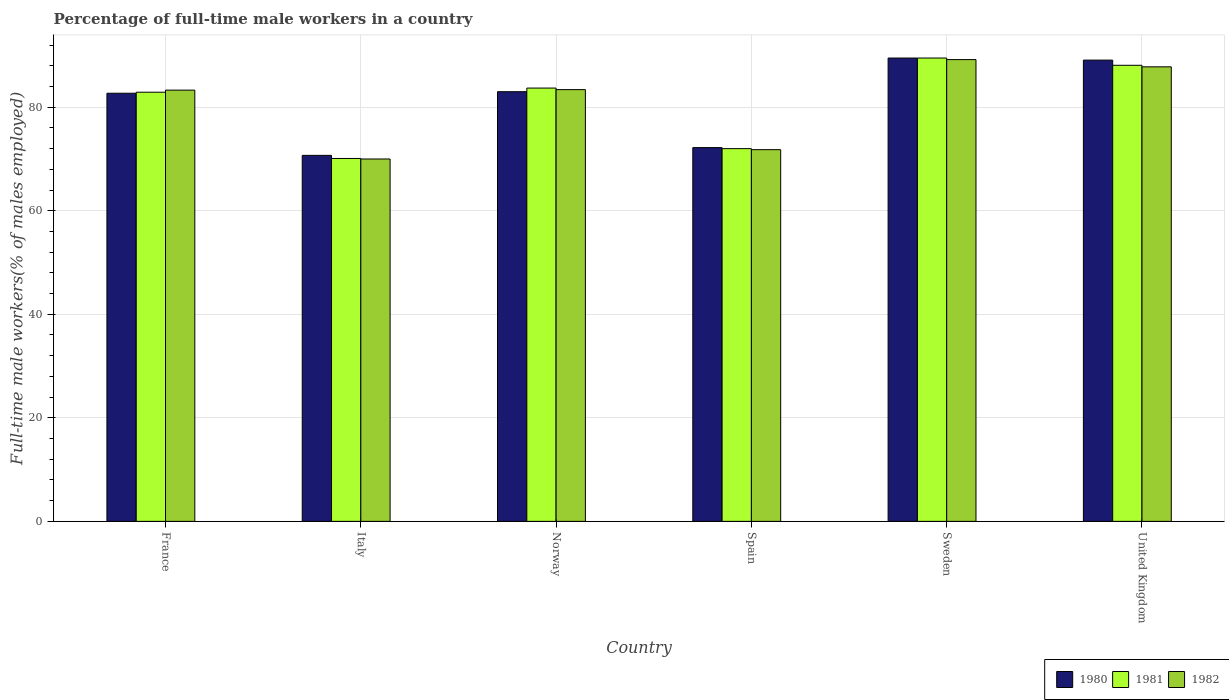How many different coloured bars are there?
Your response must be concise. 3. Are the number of bars on each tick of the X-axis equal?
Provide a short and direct response. Yes. How many bars are there on the 3rd tick from the right?
Offer a very short reply. 3. What is the label of the 3rd group of bars from the left?
Provide a succinct answer. Norway. What is the percentage of full-time male workers in 1981 in Italy?
Make the answer very short. 70.1. Across all countries, what is the maximum percentage of full-time male workers in 1982?
Offer a terse response. 89.2. Across all countries, what is the minimum percentage of full-time male workers in 1980?
Provide a short and direct response. 70.7. In which country was the percentage of full-time male workers in 1980 maximum?
Offer a terse response. Sweden. What is the total percentage of full-time male workers in 1982 in the graph?
Your answer should be very brief. 485.5. What is the difference between the percentage of full-time male workers in 1981 in France and that in Sweden?
Your response must be concise. -6.6. What is the difference between the percentage of full-time male workers in 1982 in Norway and the percentage of full-time male workers in 1980 in Italy?
Offer a very short reply. 12.7. What is the average percentage of full-time male workers in 1980 per country?
Keep it short and to the point. 81.2. What is the difference between the percentage of full-time male workers of/in 1982 and percentage of full-time male workers of/in 1981 in Norway?
Offer a very short reply. -0.3. In how many countries, is the percentage of full-time male workers in 1982 greater than 48 %?
Your response must be concise. 6. What is the ratio of the percentage of full-time male workers in 1980 in Norway to that in United Kingdom?
Offer a terse response. 0.93. What is the difference between the highest and the second highest percentage of full-time male workers in 1980?
Provide a short and direct response. -0.4. What is the difference between the highest and the lowest percentage of full-time male workers in 1981?
Your answer should be compact. 19.4. In how many countries, is the percentage of full-time male workers in 1982 greater than the average percentage of full-time male workers in 1982 taken over all countries?
Your answer should be compact. 4. Is the sum of the percentage of full-time male workers in 1980 in Spain and United Kingdom greater than the maximum percentage of full-time male workers in 1981 across all countries?
Your response must be concise. Yes. What does the 1st bar from the left in Sweden represents?
Make the answer very short. 1980. Is it the case that in every country, the sum of the percentage of full-time male workers in 1981 and percentage of full-time male workers in 1982 is greater than the percentage of full-time male workers in 1980?
Keep it short and to the point. Yes. How many bars are there?
Provide a succinct answer. 18. Are all the bars in the graph horizontal?
Keep it short and to the point. No. How many countries are there in the graph?
Offer a very short reply. 6. What is the difference between two consecutive major ticks on the Y-axis?
Your answer should be compact. 20. Are the values on the major ticks of Y-axis written in scientific E-notation?
Provide a short and direct response. No. Does the graph contain any zero values?
Your answer should be compact. No. Does the graph contain grids?
Ensure brevity in your answer.  Yes. Where does the legend appear in the graph?
Keep it short and to the point. Bottom right. How many legend labels are there?
Provide a succinct answer. 3. What is the title of the graph?
Offer a terse response. Percentage of full-time male workers in a country. What is the label or title of the X-axis?
Provide a short and direct response. Country. What is the label or title of the Y-axis?
Offer a terse response. Full-time male workers(% of males employed). What is the Full-time male workers(% of males employed) of 1980 in France?
Ensure brevity in your answer.  82.7. What is the Full-time male workers(% of males employed) in 1981 in France?
Give a very brief answer. 82.9. What is the Full-time male workers(% of males employed) of 1982 in France?
Offer a terse response. 83.3. What is the Full-time male workers(% of males employed) in 1980 in Italy?
Your response must be concise. 70.7. What is the Full-time male workers(% of males employed) of 1981 in Italy?
Make the answer very short. 70.1. What is the Full-time male workers(% of males employed) of 1982 in Italy?
Keep it short and to the point. 70. What is the Full-time male workers(% of males employed) of 1981 in Norway?
Offer a terse response. 83.7. What is the Full-time male workers(% of males employed) of 1982 in Norway?
Make the answer very short. 83.4. What is the Full-time male workers(% of males employed) in 1980 in Spain?
Provide a short and direct response. 72.2. What is the Full-time male workers(% of males employed) of 1982 in Spain?
Provide a succinct answer. 71.8. What is the Full-time male workers(% of males employed) of 1980 in Sweden?
Provide a succinct answer. 89.5. What is the Full-time male workers(% of males employed) in 1981 in Sweden?
Ensure brevity in your answer.  89.5. What is the Full-time male workers(% of males employed) in 1982 in Sweden?
Provide a short and direct response. 89.2. What is the Full-time male workers(% of males employed) of 1980 in United Kingdom?
Your answer should be very brief. 89.1. What is the Full-time male workers(% of males employed) of 1981 in United Kingdom?
Offer a very short reply. 88.1. What is the Full-time male workers(% of males employed) in 1982 in United Kingdom?
Your answer should be compact. 87.8. Across all countries, what is the maximum Full-time male workers(% of males employed) in 1980?
Give a very brief answer. 89.5. Across all countries, what is the maximum Full-time male workers(% of males employed) of 1981?
Ensure brevity in your answer.  89.5. Across all countries, what is the maximum Full-time male workers(% of males employed) of 1982?
Make the answer very short. 89.2. Across all countries, what is the minimum Full-time male workers(% of males employed) in 1980?
Ensure brevity in your answer.  70.7. Across all countries, what is the minimum Full-time male workers(% of males employed) of 1981?
Your answer should be compact. 70.1. Across all countries, what is the minimum Full-time male workers(% of males employed) of 1982?
Your response must be concise. 70. What is the total Full-time male workers(% of males employed) in 1980 in the graph?
Provide a succinct answer. 487.2. What is the total Full-time male workers(% of males employed) of 1981 in the graph?
Provide a succinct answer. 486.3. What is the total Full-time male workers(% of males employed) in 1982 in the graph?
Your answer should be very brief. 485.5. What is the difference between the Full-time male workers(% of males employed) in 1981 in France and that in Italy?
Offer a terse response. 12.8. What is the difference between the Full-time male workers(% of males employed) in 1980 in France and that in Norway?
Provide a short and direct response. -0.3. What is the difference between the Full-time male workers(% of males employed) in 1981 in France and that in Norway?
Your answer should be compact. -0.8. What is the difference between the Full-time male workers(% of males employed) of 1982 in France and that in Norway?
Offer a very short reply. -0.1. What is the difference between the Full-time male workers(% of males employed) of 1981 in France and that in Sweden?
Make the answer very short. -6.6. What is the difference between the Full-time male workers(% of males employed) of 1982 in France and that in Sweden?
Provide a short and direct response. -5.9. What is the difference between the Full-time male workers(% of males employed) in 1981 in France and that in United Kingdom?
Your answer should be compact. -5.2. What is the difference between the Full-time male workers(% of males employed) in 1981 in Italy and that in Norway?
Your answer should be compact. -13.6. What is the difference between the Full-time male workers(% of males employed) in 1982 in Italy and that in Norway?
Offer a very short reply. -13.4. What is the difference between the Full-time male workers(% of males employed) of 1980 in Italy and that in Spain?
Offer a very short reply. -1.5. What is the difference between the Full-time male workers(% of males employed) in 1981 in Italy and that in Spain?
Offer a terse response. -1.9. What is the difference between the Full-time male workers(% of males employed) of 1980 in Italy and that in Sweden?
Offer a very short reply. -18.8. What is the difference between the Full-time male workers(% of males employed) of 1981 in Italy and that in Sweden?
Your answer should be compact. -19.4. What is the difference between the Full-time male workers(% of males employed) in 1982 in Italy and that in Sweden?
Offer a very short reply. -19.2. What is the difference between the Full-time male workers(% of males employed) of 1980 in Italy and that in United Kingdom?
Your answer should be very brief. -18.4. What is the difference between the Full-time male workers(% of males employed) of 1982 in Italy and that in United Kingdom?
Offer a terse response. -17.8. What is the difference between the Full-time male workers(% of males employed) of 1981 in Norway and that in Spain?
Your answer should be very brief. 11.7. What is the difference between the Full-time male workers(% of males employed) of 1980 in Norway and that in Sweden?
Ensure brevity in your answer.  -6.5. What is the difference between the Full-time male workers(% of males employed) of 1980 in Norway and that in United Kingdom?
Keep it short and to the point. -6.1. What is the difference between the Full-time male workers(% of males employed) of 1980 in Spain and that in Sweden?
Provide a short and direct response. -17.3. What is the difference between the Full-time male workers(% of males employed) of 1981 in Spain and that in Sweden?
Your response must be concise. -17.5. What is the difference between the Full-time male workers(% of males employed) of 1982 in Spain and that in Sweden?
Give a very brief answer. -17.4. What is the difference between the Full-time male workers(% of males employed) in 1980 in Spain and that in United Kingdom?
Provide a succinct answer. -16.9. What is the difference between the Full-time male workers(% of males employed) of 1981 in Spain and that in United Kingdom?
Your response must be concise. -16.1. What is the difference between the Full-time male workers(% of males employed) in 1982 in Spain and that in United Kingdom?
Provide a succinct answer. -16. What is the difference between the Full-time male workers(% of males employed) in 1980 in Sweden and that in United Kingdom?
Ensure brevity in your answer.  0.4. What is the difference between the Full-time male workers(% of males employed) of 1982 in Sweden and that in United Kingdom?
Keep it short and to the point. 1.4. What is the difference between the Full-time male workers(% of males employed) of 1980 in France and the Full-time male workers(% of males employed) of 1981 in Italy?
Make the answer very short. 12.6. What is the difference between the Full-time male workers(% of males employed) of 1981 in France and the Full-time male workers(% of males employed) of 1982 in Italy?
Provide a short and direct response. 12.9. What is the difference between the Full-time male workers(% of males employed) of 1980 in France and the Full-time male workers(% of males employed) of 1981 in Norway?
Give a very brief answer. -1. What is the difference between the Full-time male workers(% of males employed) of 1981 in France and the Full-time male workers(% of males employed) of 1982 in Norway?
Offer a very short reply. -0.5. What is the difference between the Full-time male workers(% of males employed) of 1980 in France and the Full-time male workers(% of males employed) of 1981 in Spain?
Ensure brevity in your answer.  10.7. What is the difference between the Full-time male workers(% of males employed) in 1980 in France and the Full-time male workers(% of males employed) in 1981 in Sweden?
Keep it short and to the point. -6.8. What is the difference between the Full-time male workers(% of males employed) of 1981 in France and the Full-time male workers(% of males employed) of 1982 in Sweden?
Make the answer very short. -6.3. What is the difference between the Full-time male workers(% of males employed) in 1980 in France and the Full-time male workers(% of males employed) in 1981 in United Kingdom?
Ensure brevity in your answer.  -5.4. What is the difference between the Full-time male workers(% of males employed) of 1980 in France and the Full-time male workers(% of males employed) of 1982 in United Kingdom?
Your answer should be very brief. -5.1. What is the difference between the Full-time male workers(% of males employed) of 1981 in France and the Full-time male workers(% of males employed) of 1982 in United Kingdom?
Offer a terse response. -4.9. What is the difference between the Full-time male workers(% of males employed) of 1980 in Italy and the Full-time male workers(% of males employed) of 1982 in Norway?
Your response must be concise. -12.7. What is the difference between the Full-time male workers(% of males employed) in 1980 in Italy and the Full-time male workers(% of males employed) in 1982 in Spain?
Your response must be concise. -1.1. What is the difference between the Full-time male workers(% of males employed) of 1980 in Italy and the Full-time male workers(% of males employed) of 1981 in Sweden?
Offer a very short reply. -18.8. What is the difference between the Full-time male workers(% of males employed) in 1980 in Italy and the Full-time male workers(% of males employed) in 1982 in Sweden?
Your response must be concise. -18.5. What is the difference between the Full-time male workers(% of males employed) in 1981 in Italy and the Full-time male workers(% of males employed) in 1982 in Sweden?
Your answer should be compact. -19.1. What is the difference between the Full-time male workers(% of males employed) in 1980 in Italy and the Full-time male workers(% of males employed) in 1981 in United Kingdom?
Provide a succinct answer. -17.4. What is the difference between the Full-time male workers(% of males employed) of 1980 in Italy and the Full-time male workers(% of males employed) of 1982 in United Kingdom?
Provide a short and direct response. -17.1. What is the difference between the Full-time male workers(% of males employed) of 1981 in Italy and the Full-time male workers(% of males employed) of 1982 in United Kingdom?
Your answer should be very brief. -17.7. What is the difference between the Full-time male workers(% of males employed) in 1980 in Norway and the Full-time male workers(% of males employed) in 1982 in Spain?
Your response must be concise. 11.2. What is the difference between the Full-time male workers(% of males employed) of 1980 in Norway and the Full-time male workers(% of males employed) of 1981 in Sweden?
Offer a terse response. -6.5. What is the difference between the Full-time male workers(% of males employed) of 1980 in Norway and the Full-time male workers(% of males employed) of 1982 in Sweden?
Offer a very short reply. -6.2. What is the difference between the Full-time male workers(% of males employed) of 1981 in Norway and the Full-time male workers(% of males employed) of 1982 in United Kingdom?
Ensure brevity in your answer.  -4.1. What is the difference between the Full-time male workers(% of males employed) in 1980 in Spain and the Full-time male workers(% of males employed) in 1981 in Sweden?
Offer a terse response. -17.3. What is the difference between the Full-time male workers(% of males employed) of 1981 in Spain and the Full-time male workers(% of males employed) of 1982 in Sweden?
Offer a very short reply. -17.2. What is the difference between the Full-time male workers(% of males employed) in 1980 in Spain and the Full-time male workers(% of males employed) in 1981 in United Kingdom?
Offer a very short reply. -15.9. What is the difference between the Full-time male workers(% of males employed) of 1980 in Spain and the Full-time male workers(% of males employed) of 1982 in United Kingdom?
Your answer should be compact. -15.6. What is the difference between the Full-time male workers(% of males employed) in 1981 in Spain and the Full-time male workers(% of males employed) in 1982 in United Kingdom?
Ensure brevity in your answer.  -15.8. What is the average Full-time male workers(% of males employed) of 1980 per country?
Provide a short and direct response. 81.2. What is the average Full-time male workers(% of males employed) of 1981 per country?
Offer a very short reply. 81.05. What is the average Full-time male workers(% of males employed) of 1982 per country?
Give a very brief answer. 80.92. What is the difference between the Full-time male workers(% of males employed) in 1980 and Full-time male workers(% of males employed) in 1981 in France?
Provide a succinct answer. -0.2. What is the difference between the Full-time male workers(% of males employed) in 1980 and Full-time male workers(% of males employed) in 1982 in Italy?
Your answer should be compact. 0.7. What is the difference between the Full-time male workers(% of males employed) of 1981 and Full-time male workers(% of males employed) of 1982 in Italy?
Ensure brevity in your answer.  0.1. What is the difference between the Full-time male workers(% of males employed) of 1980 and Full-time male workers(% of males employed) of 1982 in Norway?
Keep it short and to the point. -0.4. What is the difference between the Full-time male workers(% of males employed) of 1981 and Full-time male workers(% of males employed) of 1982 in Norway?
Make the answer very short. 0.3. What is the difference between the Full-time male workers(% of males employed) in 1980 and Full-time male workers(% of males employed) in 1982 in Spain?
Your answer should be very brief. 0.4. What is the difference between the Full-time male workers(% of males employed) of 1981 and Full-time male workers(% of males employed) of 1982 in Spain?
Your answer should be very brief. 0.2. What is the difference between the Full-time male workers(% of males employed) in 1980 and Full-time male workers(% of males employed) in 1982 in United Kingdom?
Make the answer very short. 1.3. What is the difference between the Full-time male workers(% of males employed) of 1981 and Full-time male workers(% of males employed) of 1982 in United Kingdom?
Offer a very short reply. 0.3. What is the ratio of the Full-time male workers(% of males employed) in 1980 in France to that in Italy?
Ensure brevity in your answer.  1.17. What is the ratio of the Full-time male workers(% of males employed) in 1981 in France to that in Italy?
Provide a short and direct response. 1.18. What is the ratio of the Full-time male workers(% of males employed) of 1982 in France to that in Italy?
Ensure brevity in your answer.  1.19. What is the ratio of the Full-time male workers(% of males employed) in 1980 in France to that in Norway?
Keep it short and to the point. 1. What is the ratio of the Full-time male workers(% of males employed) in 1981 in France to that in Norway?
Give a very brief answer. 0.99. What is the ratio of the Full-time male workers(% of males employed) of 1980 in France to that in Spain?
Your answer should be compact. 1.15. What is the ratio of the Full-time male workers(% of males employed) of 1981 in France to that in Spain?
Give a very brief answer. 1.15. What is the ratio of the Full-time male workers(% of males employed) of 1982 in France to that in Spain?
Keep it short and to the point. 1.16. What is the ratio of the Full-time male workers(% of males employed) in 1980 in France to that in Sweden?
Your answer should be very brief. 0.92. What is the ratio of the Full-time male workers(% of males employed) of 1981 in France to that in Sweden?
Your answer should be very brief. 0.93. What is the ratio of the Full-time male workers(% of males employed) in 1982 in France to that in Sweden?
Provide a succinct answer. 0.93. What is the ratio of the Full-time male workers(% of males employed) of 1980 in France to that in United Kingdom?
Keep it short and to the point. 0.93. What is the ratio of the Full-time male workers(% of males employed) in 1981 in France to that in United Kingdom?
Make the answer very short. 0.94. What is the ratio of the Full-time male workers(% of males employed) of 1982 in France to that in United Kingdom?
Keep it short and to the point. 0.95. What is the ratio of the Full-time male workers(% of males employed) of 1980 in Italy to that in Norway?
Your response must be concise. 0.85. What is the ratio of the Full-time male workers(% of males employed) of 1981 in Italy to that in Norway?
Your answer should be compact. 0.84. What is the ratio of the Full-time male workers(% of males employed) in 1982 in Italy to that in Norway?
Offer a terse response. 0.84. What is the ratio of the Full-time male workers(% of males employed) of 1980 in Italy to that in Spain?
Provide a succinct answer. 0.98. What is the ratio of the Full-time male workers(% of males employed) in 1981 in Italy to that in Spain?
Provide a short and direct response. 0.97. What is the ratio of the Full-time male workers(% of males employed) of 1982 in Italy to that in Spain?
Make the answer very short. 0.97. What is the ratio of the Full-time male workers(% of males employed) in 1980 in Italy to that in Sweden?
Keep it short and to the point. 0.79. What is the ratio of the Full-time male workers(% of males employed) in 1981 in Italy to that in Sweden?
Provide a short and direct response. 0.78. What is the ratio of the Full-time male workers(% of males employed) of 1982 in Italy to that in Sweden?
Your answer should be very brief. 0.78. What is the ratio of the Full-time male workers(% of males employed) in 1980 in Italy to that in United Kingdom?
Provide a succinct answer. 0.79. What is the ratio of the Full-time male workers(% of males employed) in 1981 in Italy to that in United Kingdom?
Your answer should be very brief. 0.8. What is the ratio of the Full-time male workers(% of males employed) in 1982 in Italy to that in United Kingdom?
Provide a short and direct response. 0.8. What is the ratio of the Full-time male workers(% of males employed) of 1980 in Norway to that in Spain?
Give a very brief answer. 1.15. What is the ratio of the Full-time male workers(% of males employed) in 1981 in Norway to that in Spain?
Offer a terse response. 1.16. What is the ratio of the Full-time male workers(% of males employed) in 1982 in Norway to that in Spain?
Offer a terse response. 1.16. What is the ratio of the Full-time male workers(% of males employed) of 1980 in Norway to that in Sweden?
Your response must be concise. 0.93. What is the ratio of the Full-time male workers(% of males employed) of 1981 in Norway to that in Sweden?
Offer a terse response. 0.94. What is the ratio of the Full-time male workers(% of males employed) of 1982 in Norway to that in Sweden?
Your answer should be compact. 0.94. What is the ratio of the Full-time male workers(% of males employed) in 1980 in Norway to that in United Kingdom?
Offer a terse response. 0.93. What is the ratio of the Full-time male workers(% of males employed) in 1981 in Norway to that in United Kingdom?
Your response must be concise. 0.95. What is the ratio of the Full-time male workers(% of males employed) of 1982 in Norway to that in United Kingdom?
Ensure brevity in your answer.  0.95. What is the ratio of the Full-time male workers(% of males employed) of 1980 in Spain to that in Sweden?
Provide a short and direct response. 0.81. What is the ratio of the Full-time male workers(% of males employed) of 1981 in Spain to that in Sweden?
Make the answer very short. 0.8. What is the ratio of the Full-time male workers(% of males employed) of 1982 in Spain to that in Sweden?
Provide a short and direct response. 0.8. What is the ratio of the Full-time male workers(% of males employed) of 1980 in Spain to that in United Kingdom?
Give a very brief answer. 0.81. What is the ratio of the Full-time male workers(% of males employed) of 1981 in Spain to that in United Kingdom?
Your answer should be compact. 0.82. What is the ratio of the Full-time male workers(% of males employed) in 1982 in Spain to that in United Kingdom?
Make the answer very short. 0.82. What is the ratio of the Full-time male workers(% of males employed) in 1980 in Sweden to that in United Kingdom?
Your response must be concise. 1. What is the ratio of the Full-time male workers(% of males employed) of 1981 in Sweden to that in United Kingdom?
Your answer should be compact. 1.02. What is the ratio of the Full-time male workers(% of males employed) in 1982 in Sweden to that in United Kingdom?
Offer a very short reply. 1.02. What is the difference between the highest and the second highest Full-time male workers(% of males employed) in 1980?
Offer a terse response. 0.4. What is the difference between the highest and the second highest Full-time male workers(% of males employed) in 1981?
Keep it short and to the point. 1.4. What is the difference between the highest and the lowest Full-time male workers(% of males employed) of 1982?
Keep it short and to the point. 19.2. 